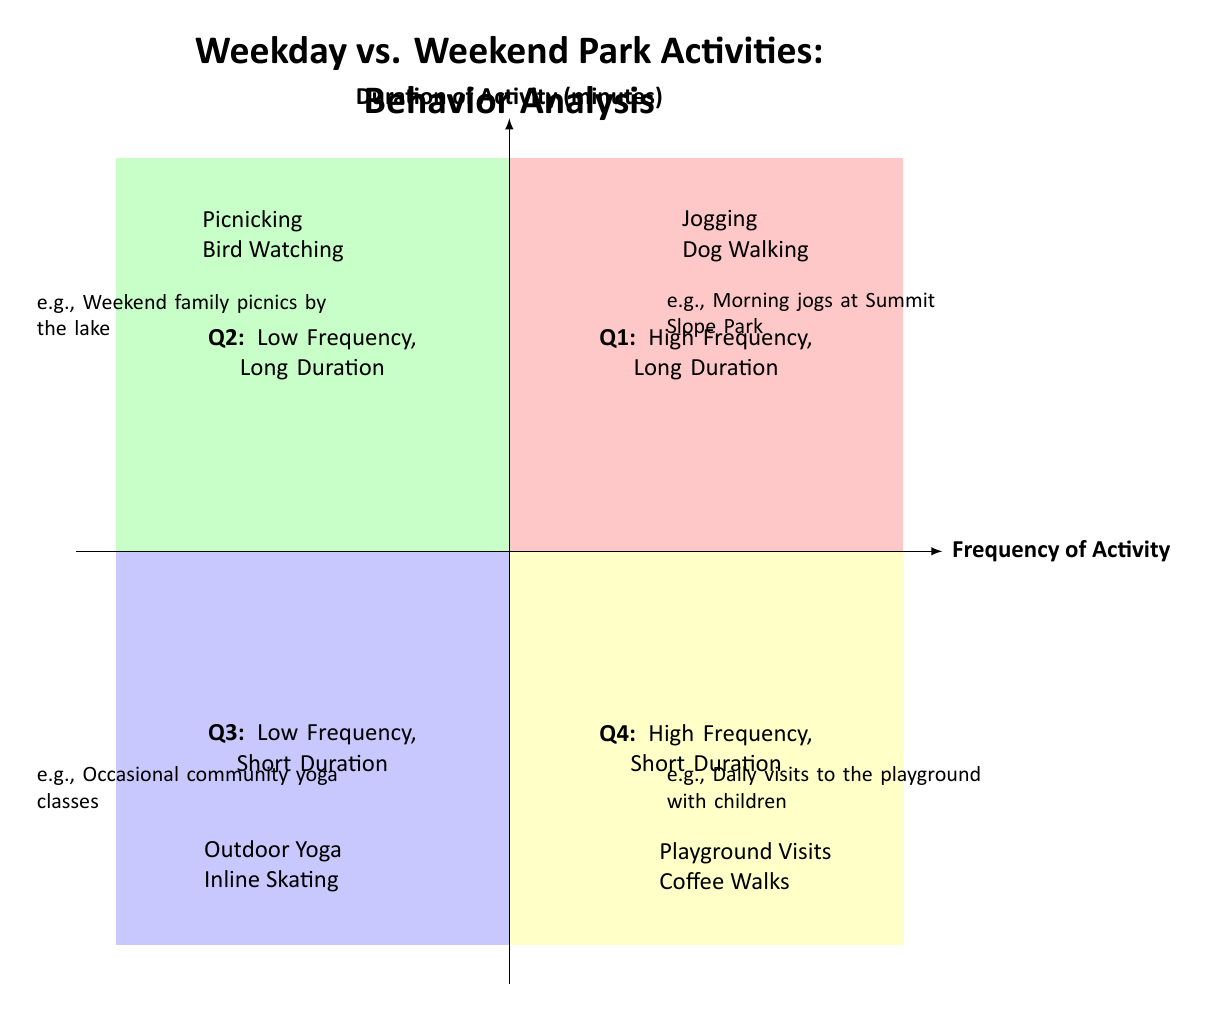What activities are categorized in Q1? Q1 represents the "High Frequency, Long Duration" quadrant. In this quadrant, the activities listed are "Jogging" and "Dog Walking".
Answer: Jogging, Dog Walking Which activity is an example of low frequency and long duration? The Q2 quadrant is labeled "Low Frequency, Long Duration". The activities in this quadrant include "Picnicking" and "Bird Watching".
Answer: Picnicking, Bird Watching How many total activities are listed in the quadrants? Each quadrant contains two activities, and there are four quadrants total. Therefore, we multiply the number of quadrants (4) by the number of activities per quadrant (2): 4 x 2 = 8.
Answer: 8 What type of activity is "Coffee Walks"? "Coffee Walks" is mentioned in Q4, which is categorized as "High Frequency, Short Duration". This indicates that it occurs often but lasts for a short amount of time.
Answer: High Frequency, Short Duration Which quadrant contains "Outdoor Yoga"? "Outdoor Yoga" is located in the Q3 quadrant, which is labeled as "Low Frequency, Short Duration". This indicates that such yoga sessions happen infrequently and last for a short duration.
Answer: Q3 What has the longest duration among the listed activities? Among the listed activities, "Picnicking" and "Bird Watching" are in the "Low Frequency, Long Duration" category. Since they are both categorized for longer durations, they share the characteristic of longer activity duration.
Answer: Picnicking, Bird Watching How does the frequency of "Playground Visits" compare to "Inline Skating"? "Playground Visits" is categorized in Q4 as "High Frequency, Short Duration", while "Inline Skating" is in Q3 as "Low Frequency, Short Duration". Thus, "Playground Visits" occurs more frequently than "Inline Skating".
Answer: More frequent What is the overall theme of the diagram? The diagram portrays the comparison of various park activities based on their frequency and duration, distinguishing between weekday and weekend behaviors of park-goers.
Answer: Park Activities Behavior Analysis 